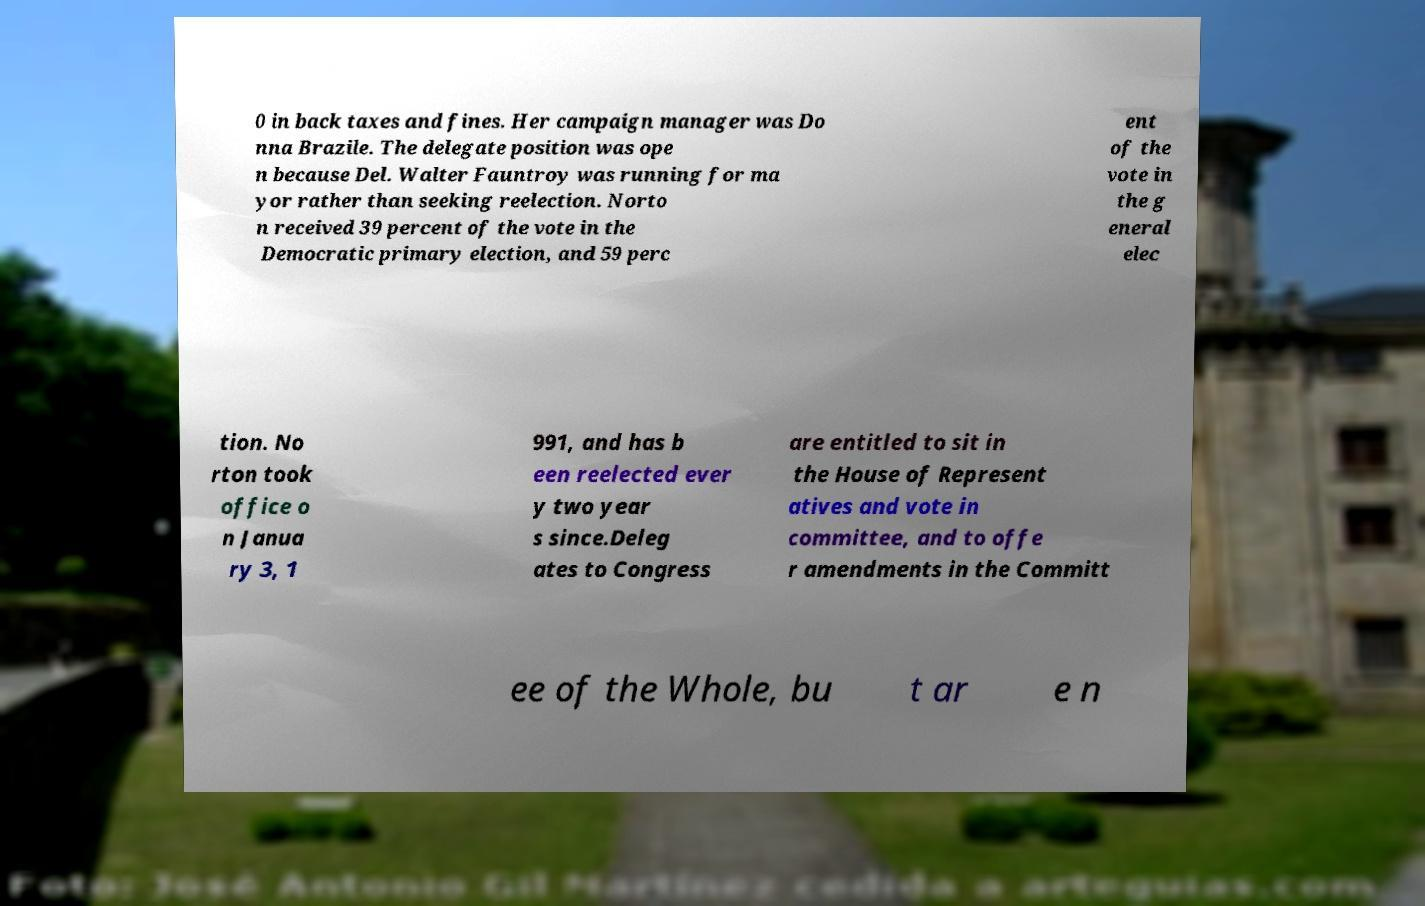There's text embedded in this image that I need extracted. Can you transcribe it verbatim? 0 in back taxes and fines. Her campaign manager was Do nna Brazile. The delegate position was ope n because Del. Walter Fauntroy was running for ma yor rather than seeking reelection. Norto n received 39 percent of the vote in the Democratic primary election, and 59 perc ent of the vote in the g eneral elec tion. No rton took office o n Janua ry 3, 1 991, and has b een reelected ever y two year s since.Deleg ates to Congress are entitled to sit in the House of Represent atives and vote in committee, and to offe r amendments in the Committ ee of the Whole, bu t ar e n 